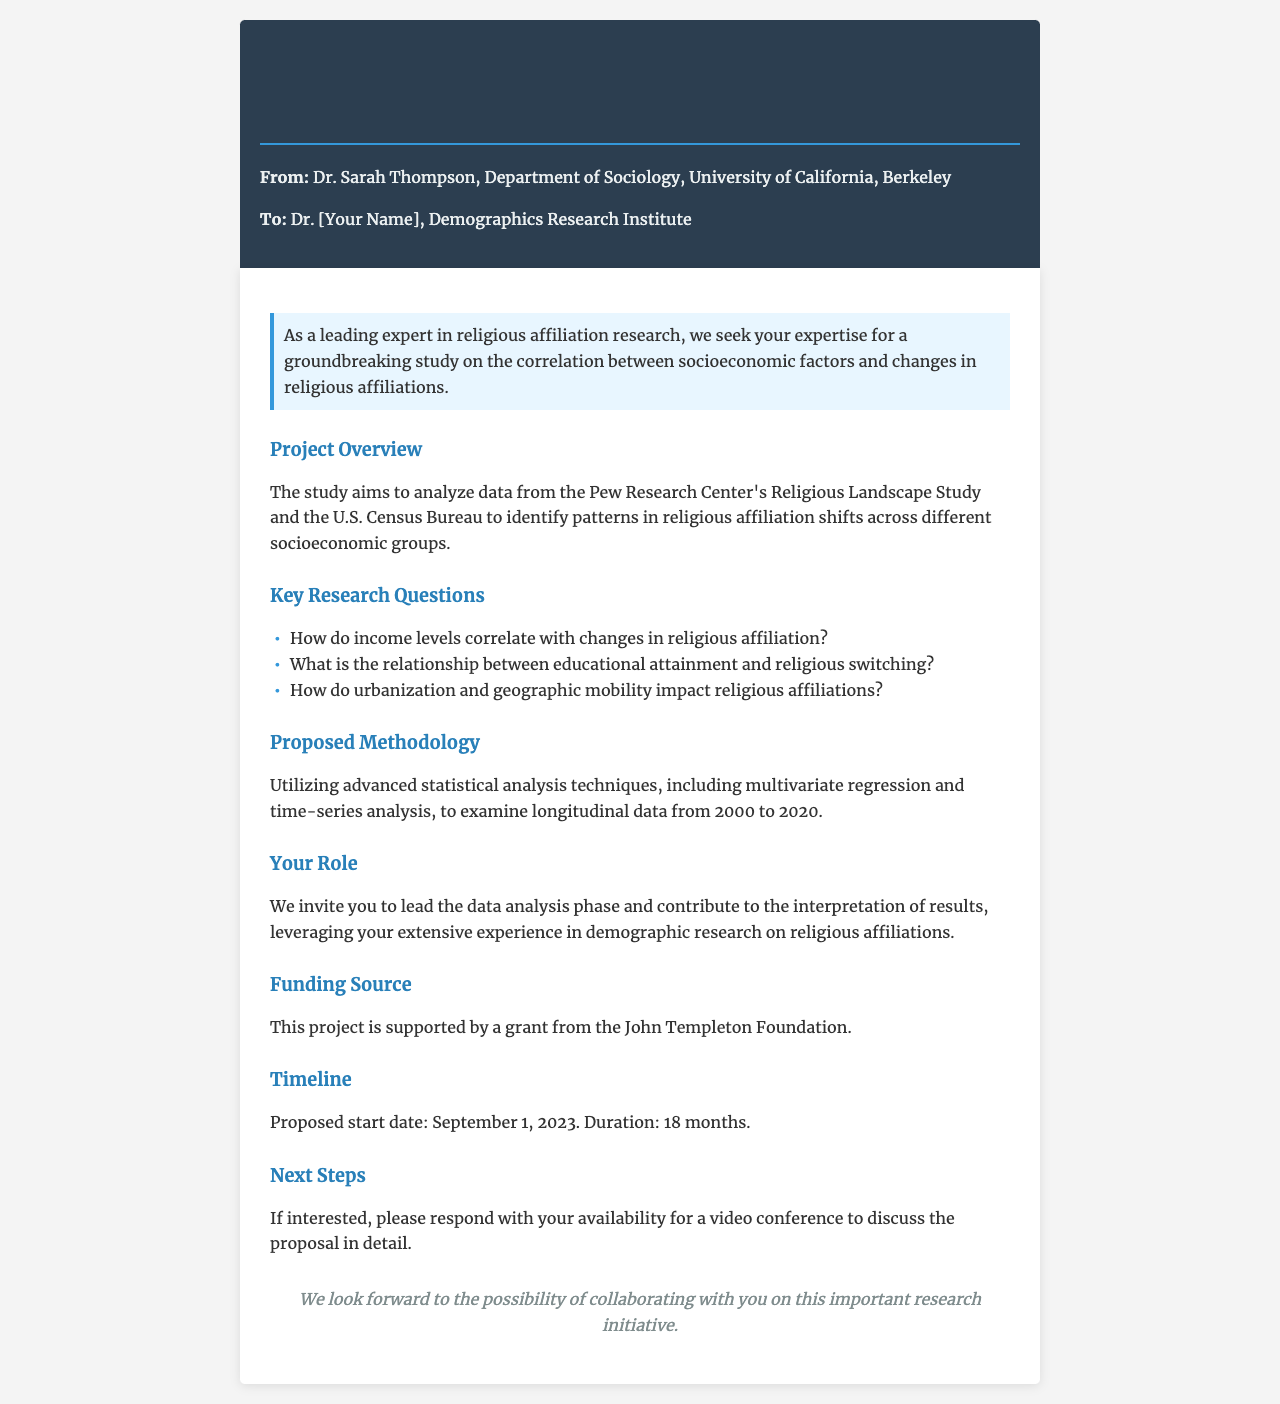What is the title of the proposal? The title of the proposal is indicated at the beginning of the document, which is "Research Collaboration Proposal: Socioeconomic Factors and Religious Affiliation Changes."
Answer: Research Collaboration Proposal: Socioeconomic Factors and Religious Affiliation Changes Who is the sender of the fax? The sender of the fax is specified in the header section of the document as "Dr. Sarah Thompson."
Answer: Dr. Sarah Thompson What is the proposed start date of the project? The proposed start date is clearly mentioned in the timeline section of the document.
Answer: September 1, 2023 How long is the duration of the project? The duration is stated in the timeline section, referring to the length of the project.
Answer: 18 months What are the socioeconomic factors mentioned in the research questions? The research questions imply a focus on income levels, educational attainment, and urbanization, which are referenced throughout the document.
Answer: Income levels, educational attainment, urbanization What statistical analysis techniques will be used in the study? The proposed methodology section outlines the techniques planned for data analysis.
Answer: Multivariate regression and time-series analysis Who is the funding source for the project? The section detailing funding mentions the organization that supports the research, which is named in the document.
Answer: John Templeton Foundation What is your suggested role in the project? The document specifies the recipient's role within the project, particularly regarding data analysis.
Answer: Lead the data analysis phase What is the main goal of the study? The goal is outlined in the project overview, focusing on a specific area of research.
Answer: Analyze data from the Pew Research Center's Religious Landscape Study and the U.S. Census Bureau What is the purpose of the next steps section? The next steps section indicates what actions are expected if the recipient is interested in the proposal.
Answer: To discuss the proposal in detail 